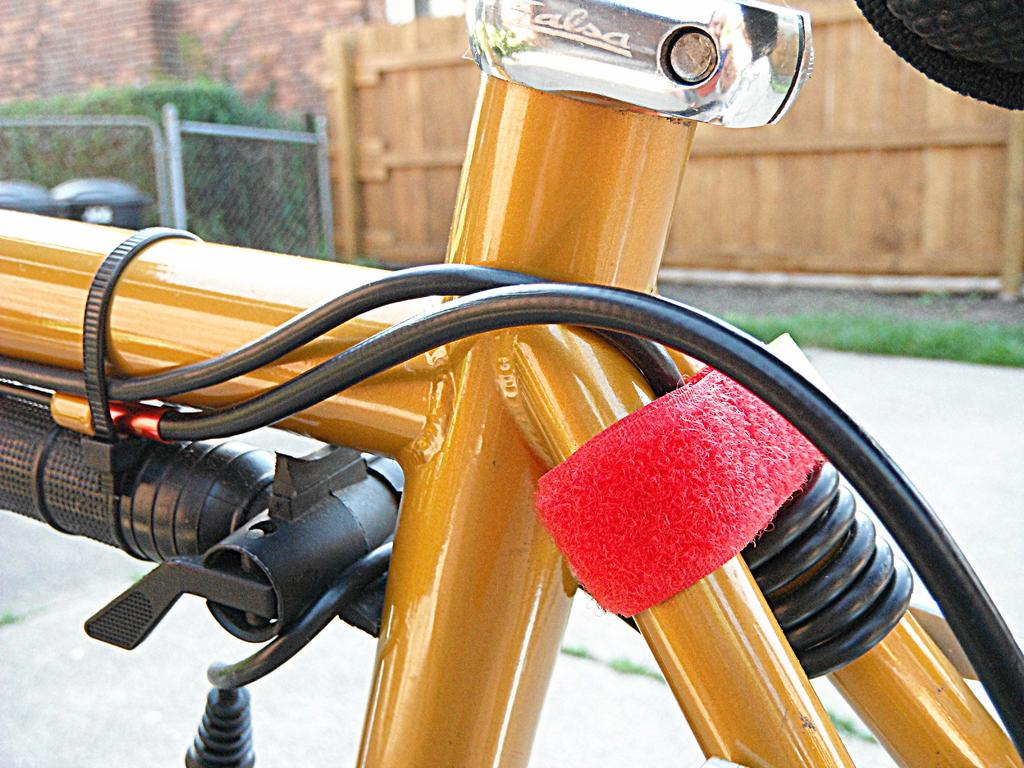What part of a bicycle can be seen in the image? There is a part of a bicycle with cables in the image. What else is present in the image besides the bicycle part? There is an object in the image. What can be seen in the background of the image? In the background of the image, there are plants, walls, dustbins, and a fence. What type of invention can be seen in the image? There is no invention present in the image; it features a part of a bicycle with cables and various background elements. What color is the tin in the image? There is no tin present in the image. 